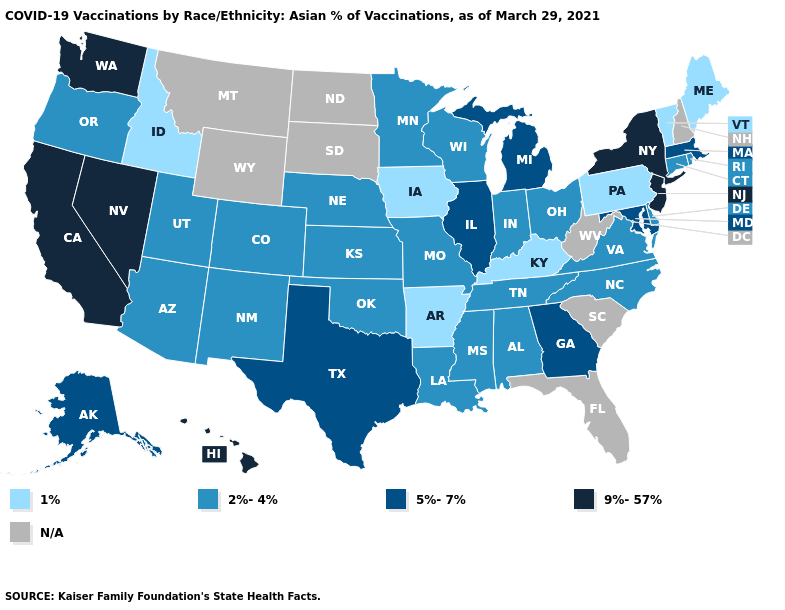Name the states that have a value in the range 1%?
Keep it brief. Arkansas, Idaho, Iowa, Kentucky, Maine, Pennsylvania, Vermont. Name the states that have a value in the range 2%-4%?
Quick response, please. Alabama, Arizona, Colorado, Connecticut, Delaware, Indiana, Kansas, Louisiana, Minnesota, Mississippi, Missouri, Nebraska, New Mexico, North Carolina, Ohio, Oklahoma, Oregon, Rhode Island, Tennessee, Utah, Virginia, Wisconsin. Name the states that have a value in the range 9%-57%?
Concise answer only. California, Hawaii, Nevada, New Jersey, New York, Washington. Name the states that have a value in the range 5%-7%?
Quick response, please. Alaska, Georgia, Illinois, Maryland, Massachusetts, Michigan, Texas. What is the value of Indiana?
Concise answer only. 2%-4%. What is the value of Washington?
Quick response, please. 9%-57%. Name the states that have a value in the range 1%?
Be succinct. Arkansas, Idaho, Iowa, Kentucky, Maine, Pennsylvania, Vermont. What is the lowest value in the South?
Short answer required. 1%. What is the value of Virginia?
Quick response, please. 2%-4%. What is the lowest value in the USA?
Write a very short answer. 1%. What is the value of New Jersey?
Give a very brief answer. 9%-57%. Among the states that border Texas , which have the lowest value?
Be succinct. Arkansas. What is the value of Arkansas?
Short answer required. 1%. What is the lowest value in the USA?
Short answer required. 1%. What is the value of Pennsylvania?
Keep it brief. 1%. 